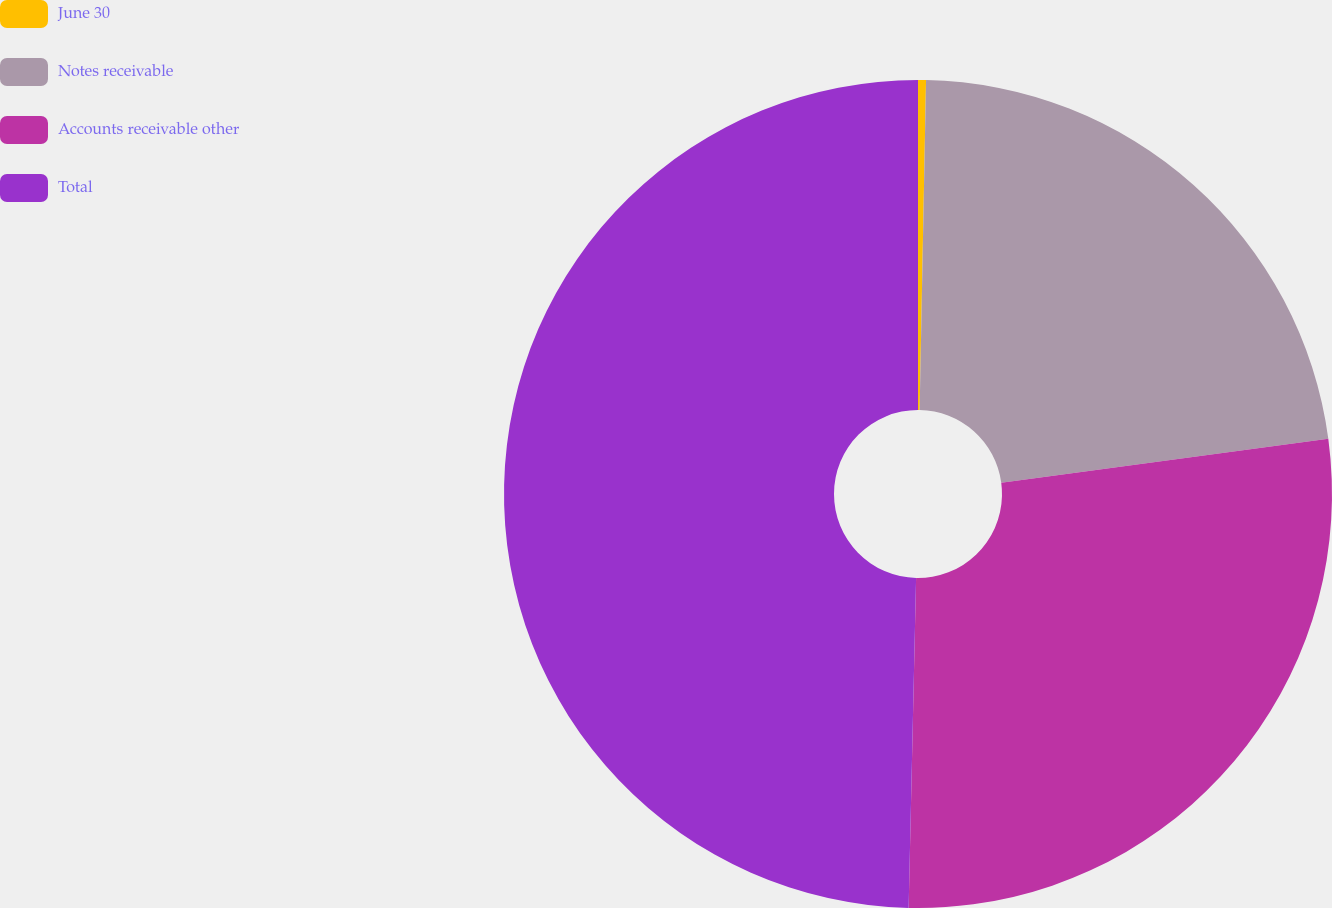Convert chart. <chart><loc_0><loc_0><loc_500><loc_500><pie_chart><fcel>June 30<fcel>Notes receivable<fcel>Accounts receivable other<fcel>Total<nl><fcel>0.31%<fcel>22.56%<fcel>27.49%<fcel>49.64%<nl></chart> 